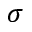Convert formula to latex. <formula><loc_0><loc_0><loc_500><loc_500>\sigma</formula> 